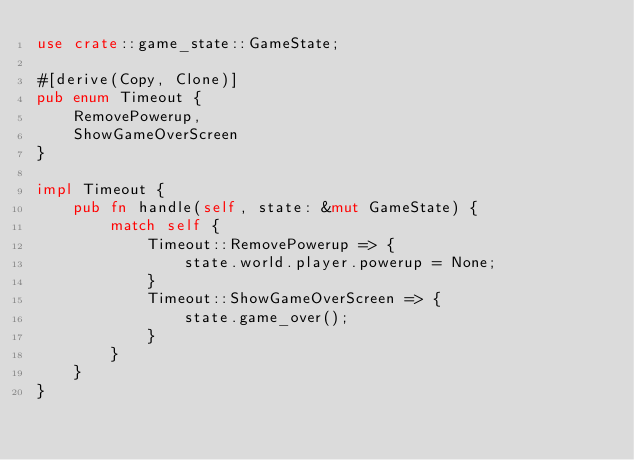<code> <loc_0><loc_0><loc_500><loc_500><_Rust_>use crate::game_state::GameState;

#[derive(Copy, Clone)]
pub enum Timeout {
    RemovePowerup,
    ShowGameOverScreen
}

impl Timeout {
    pub fn handle(self, state: &mut GameState) {
        match self {
            Timeout::RemovePowerup => {
                state.world.player.powerup = None;
            }
            Timeout::ShowGameOverScreen => {
                state.game_over();
            }
        }
    }
}
</code> 